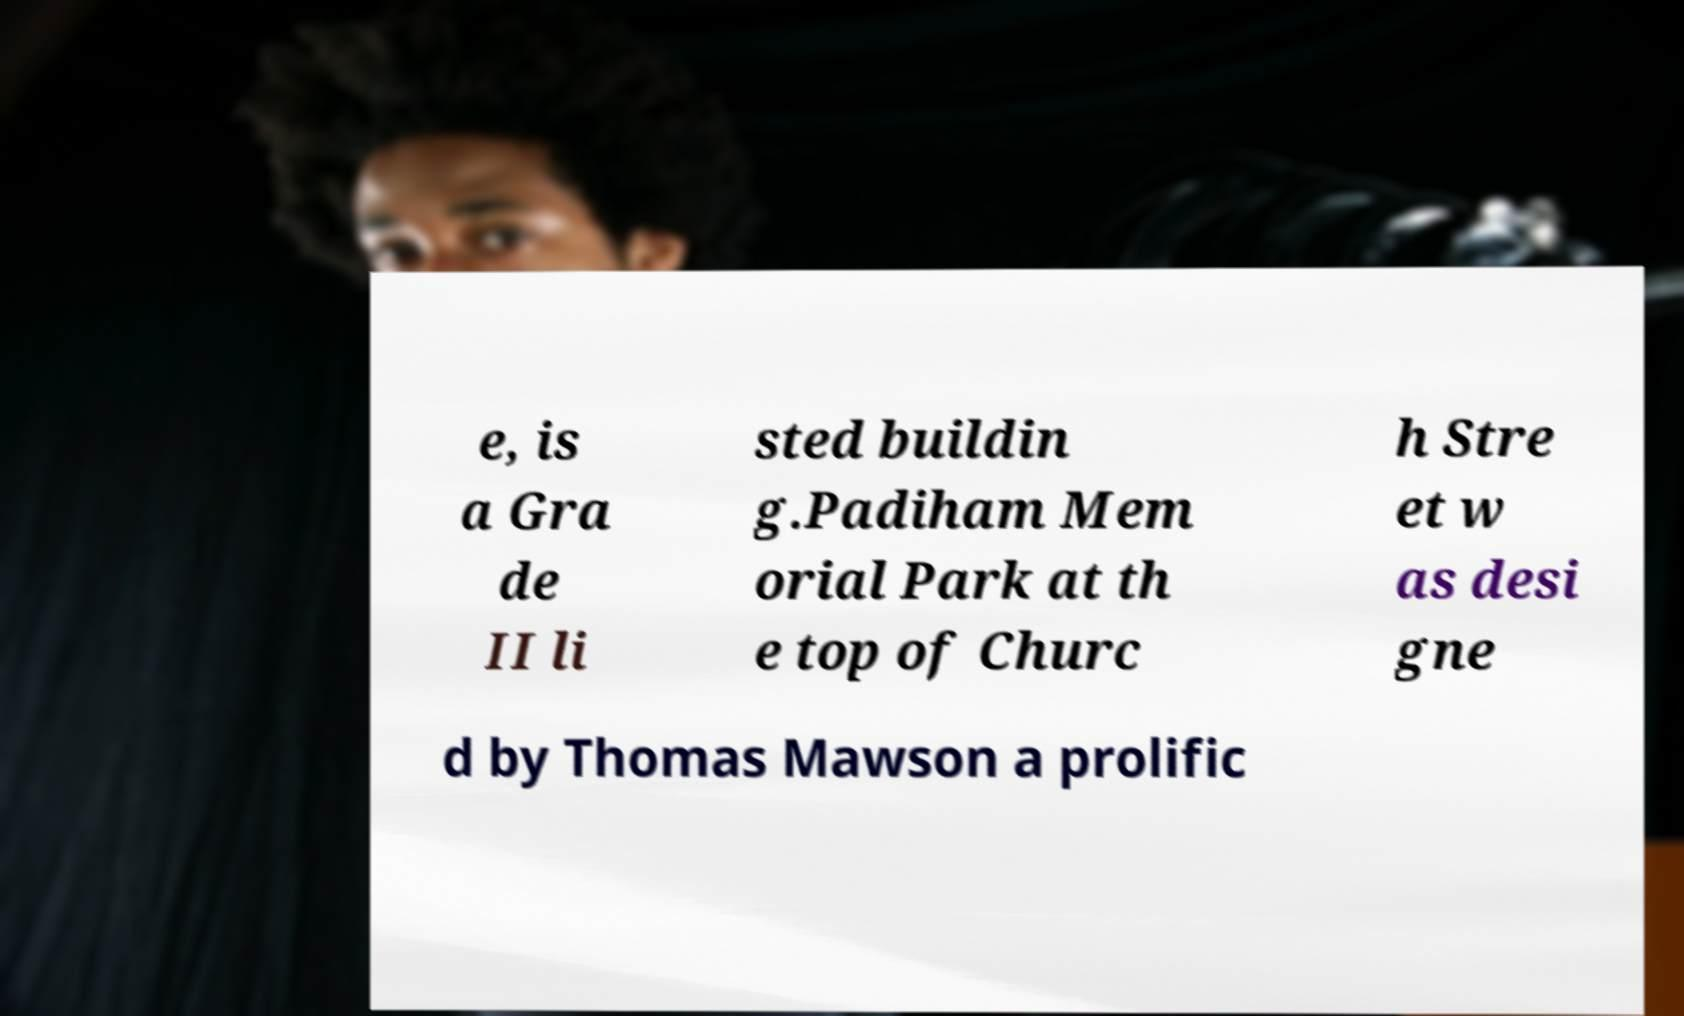Could you extract and type out the text from this image? e, is a Gra de II li sted buildin g.Padiham Mem orial Park at th e top of Churc h Stre et w as desi gne d by Thomas Mawson a prolific 